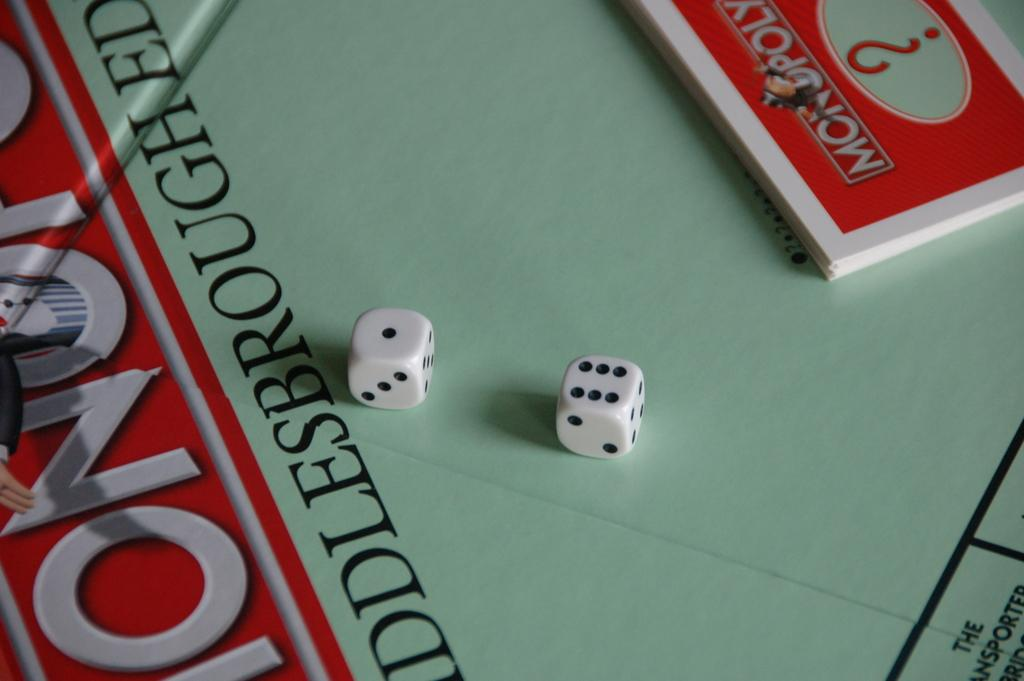What objects are present in the image that are used for games? There are two dice and cards in the image. What is located at the bottom of the image? There is a board at the bottom of the image. What can be found on the board? There is text and a picture of a person on the board. How many frogs are sitting on the cards in the image? There are no frogs present in the image; it only features dice, cards, and a board with text and a picture of a person. 